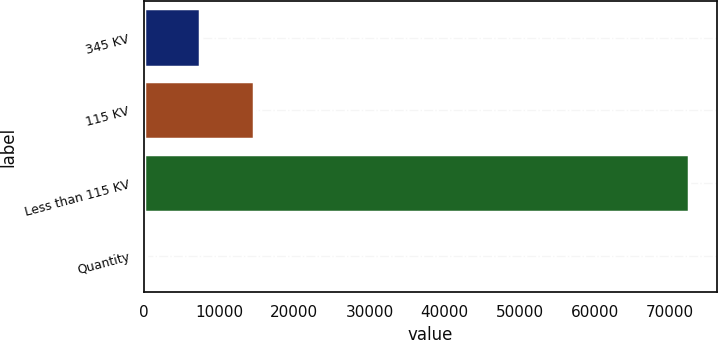Convert chart. <chart><loc_0><loc_0><loc_500><loc_500><bar_chart><fcel>345 KV<fcel>115 KV<fcel>Less than 115 KV<fcel>Quantity<nl><fcel>7455.3<fcel>14691.6<fcel>72582<fcel>219<nl></chart> 